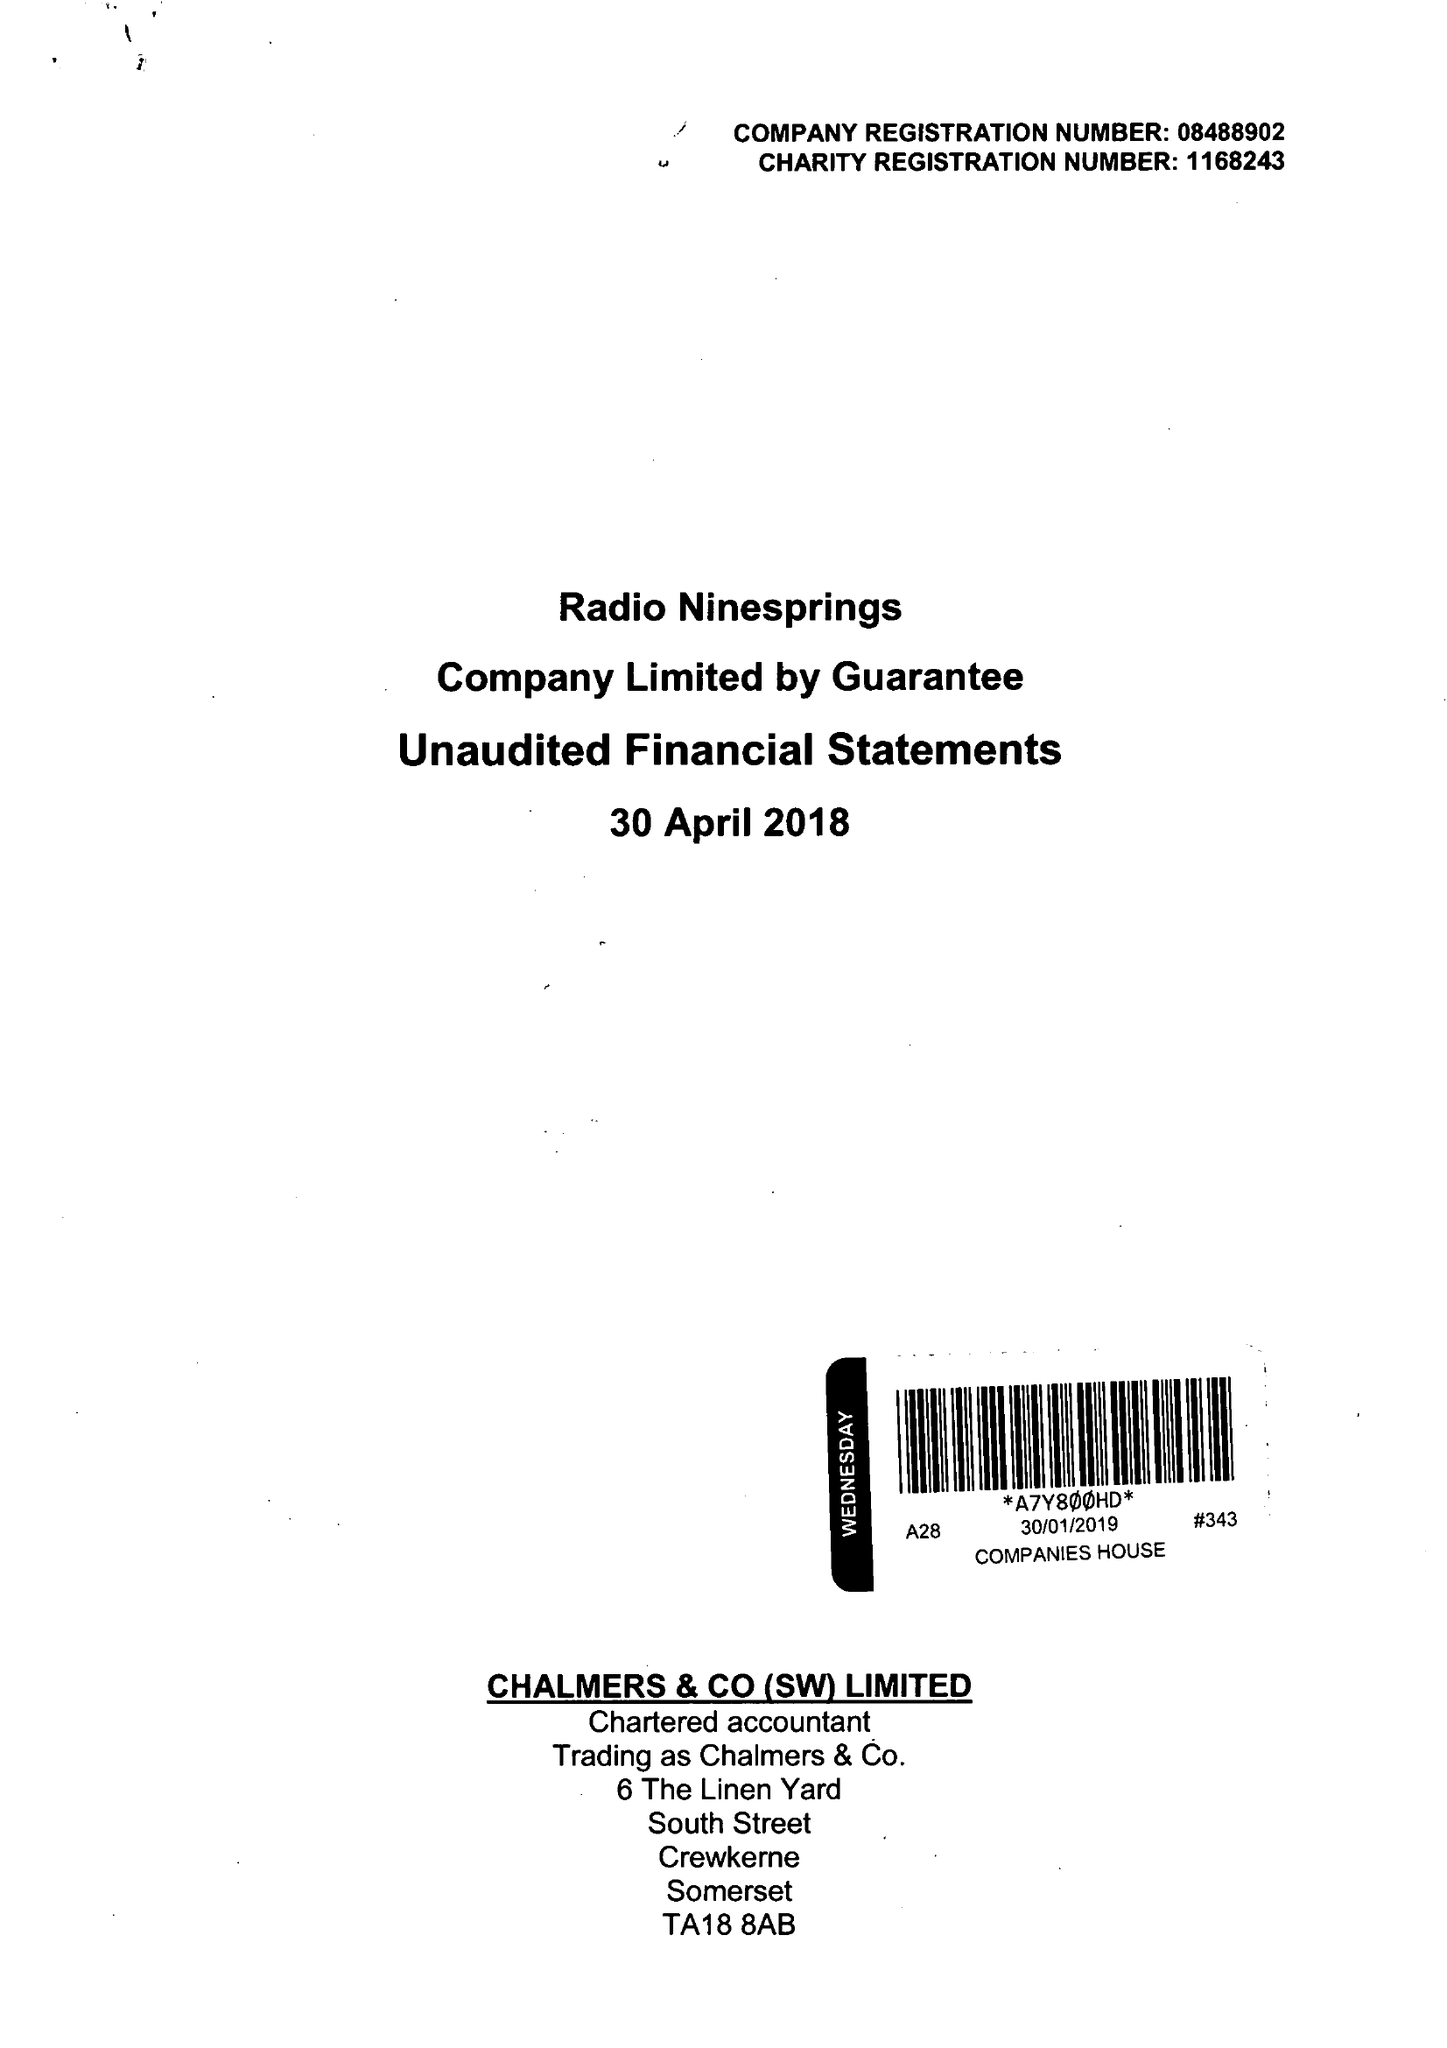What is the value for the address__postcode?
Answer the question using a single word or phrase. BA20 1TF 